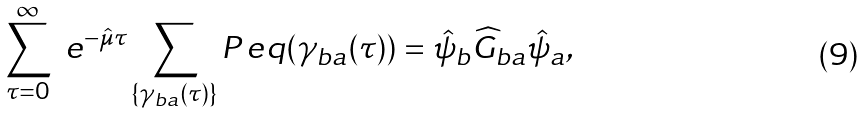Convert formula to latex. <formula><loc_0><loc_0><loc_500><loc_500>\sum _ { \tau = 0 } ^ { \infty } \ e ^ { - \hat { \mu } \tau } \sum _ { \{ \gamma _ { b a } ( \tau ) \} } P _ { \ } e q ( \gamma _ { b a } ( \tau ) ) = \hat { \psi } _ { b } \widehat { G } _ { b a } \hat { \psi } _ { a } ,</formula> 